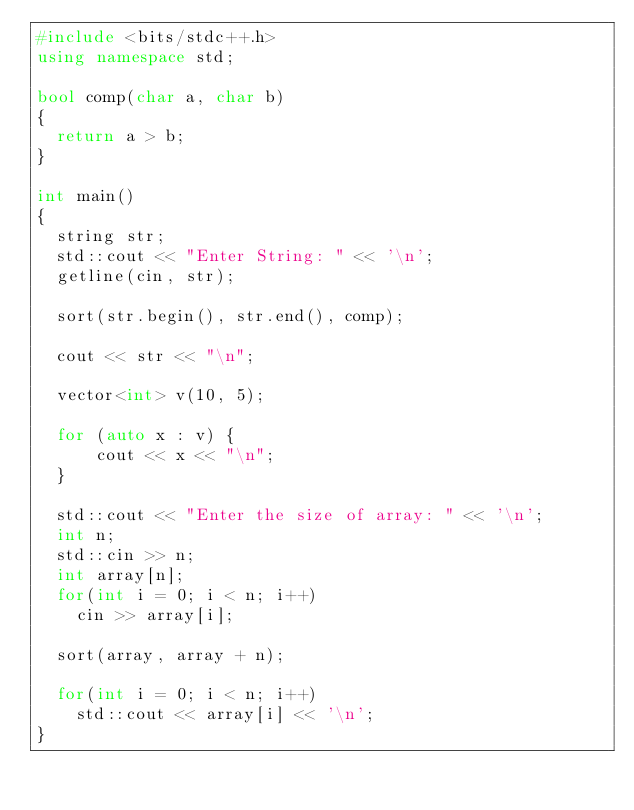Convert code to text. <code><loc_0><loc_0><loc_500><loc_500><_C++_>#include <bits/stdc++.h>
using namespace std;

bool comp(char a, char b)
{
  return a > b;
}

int main()
{
  string str;
  std::cout << "Enter String: " << '\n';
  getline(cin, str);

  sort(str.begin(), str.end(), comp);

  cout << str << "\n";

  vector<int> v(10, 5);

  for (auto x : v) {
      cout << x << "\n";
  }

  std::cout << "Enter the size of array: " << '\n';
  int n;
  std::cin >> n;
  int array[n];
  for(int i = 0; i < n; i++)
    cin >> array[i];

  sort(array, array + n);

  for(int i = 0; i < n; i++)
    std::cout << array[i] << '\n';
}
</code> 